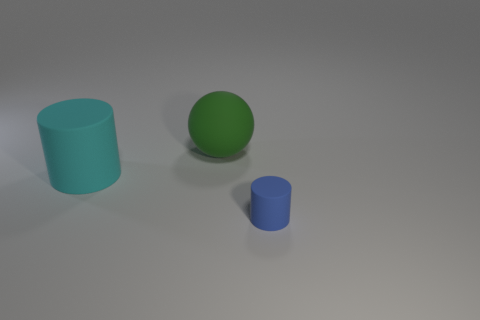Which object appears to be in the foreground due to its size? The large cyan cylinder appears to be in the foreground due to its relative size compared to the other objects. 